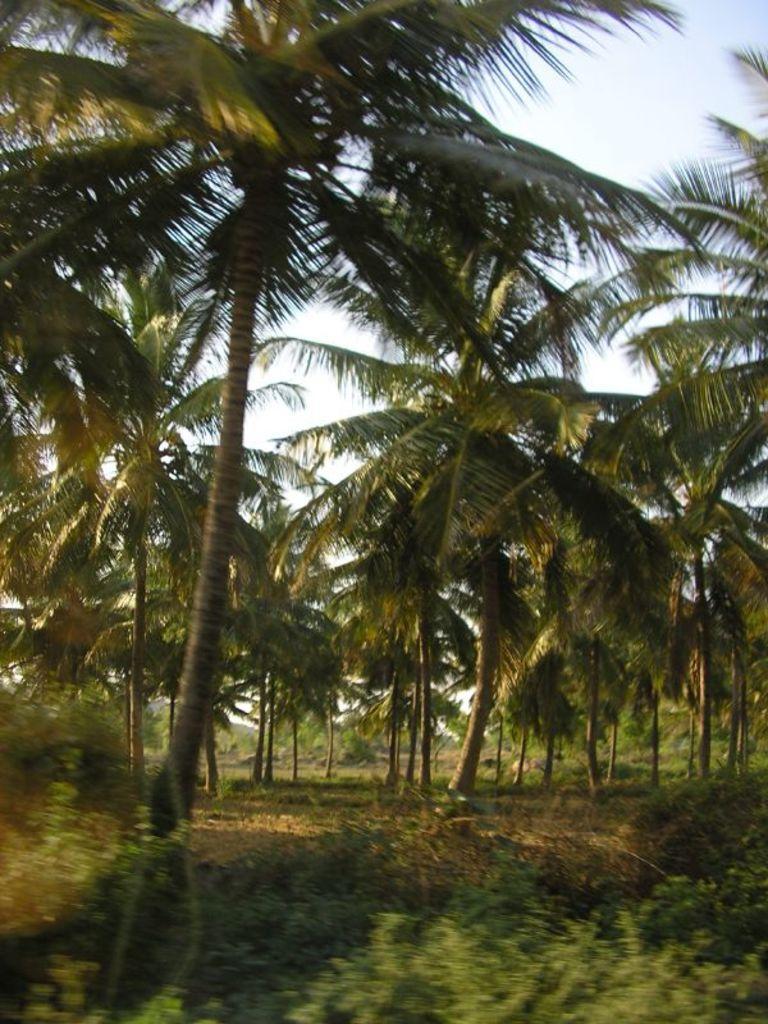Please provide a concise description of this image. In this image in the center there are trees and there is grass on the ground and the sky is cloudy. 